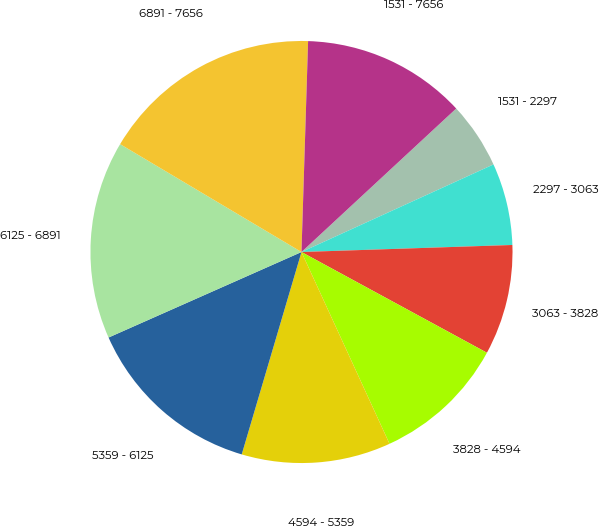Convert chart to OTSL. <chart><loc_0><loc_0><loc_500><loc_500><pie_chart><fcel>1531 - 2297<fcel>2297 - 3063<fcel>3063 - 3828<fcel>3828 - 4594<fcel>4594 - 5359<fcel>5359 - 6125<fcel>6125 - 6891<fcel>6891 - 7656<fcel>1531 - 7656<nl><fcel>5.09%<fcel>6.28%<fcel>8.45%<fcel>10.23%<fcel>11.42%<fcel>13.79%<fcel>15.18%<fcel>16.96%<fcel>12.6%<nl></chart> 